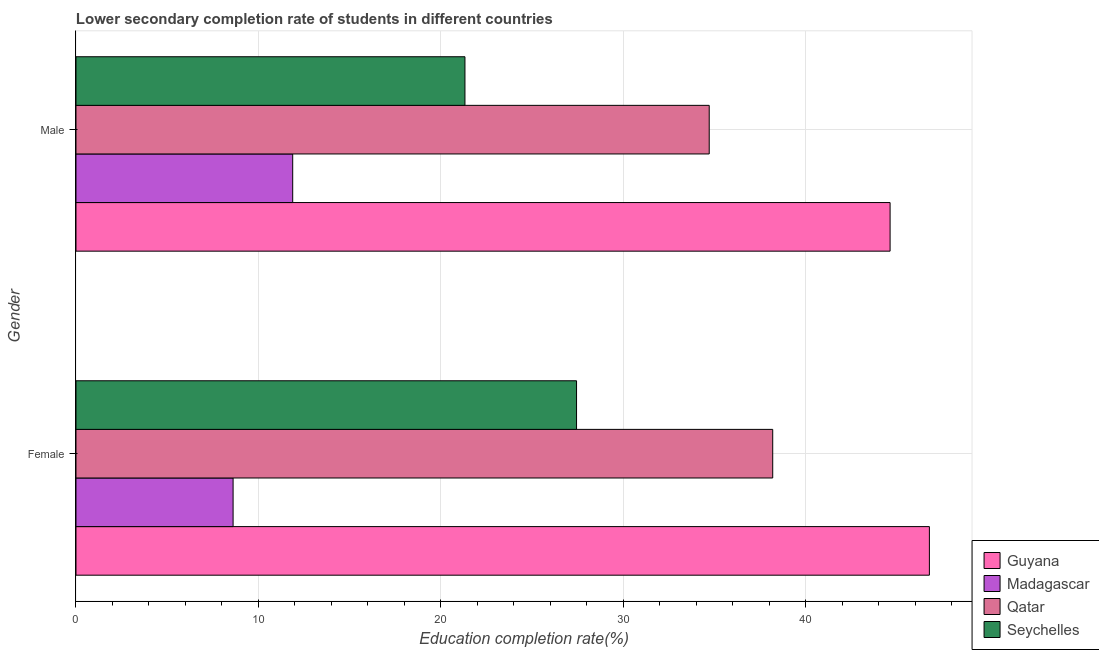Are the number of bars per tick equal to the number of legend labels?
Your answer should be compact. Yes. How many bars are there on the 1st tick from the bottom?
Give a very brief answer. 4. What is the education completion rate of female students in Qatar?
Your response must be concise. 38.18. Across all countries, what is the maximum education completion rate of male students?
Offer a terse response. 44.61. Across all countries, what is the minimum education completion rate of female students?
Your response must be concise. 8.61. In which country was the education completion rate of male students maximum?
Provide a succinct answer. Guyana. In which country was the education completion rate of female students minimum?
Offer a terse response. Madagascar. What is the total education completion rate of male students in the graph?
Give a very brief answer. 112.5. What is the difference between the education completion rate of male students in Qatar and that in Madagascar?
Make the answer very short. 22.82. What is the difference between the education completion rate of female students in Guyana and the education completion rate of male students in Madagascar?
Your answer should be very brief. 34.89. What is the average education completion rate of female students per country?
Offer a terse response. 30.24. What is the difference between the education completion rate of male students and education completion rate of female students in Guyana?
Provide a succinct answer. -2.15. What is the ratio of the education completion rate of male students in Madagascar to that in Qatar?
Offer a terse response. 0.34. What does the 4th bar from the top in Female represents?
Your response must be concise. Guyana. What does the 4th bar from the bottom in Male represents?
Offer a very short reply. Seychelles. Are all the bars in the graph horizontal?
Your answer should be very brief. Yes. Are the values on the major ticks of X-axis written in scientific E-notation?
Your answer should be compact. No. Does the graph contain any zero values?
Keep it short and to the point. No. Does the graph contain grids?
Provide a short and direct response. Yes. Where does the legend appear in the graph?
Provide a succinct answer. Bottom right. How many legend labels are there?
Offer a very short reply. 4. How are the legend labels stacked?
Ensure brevity in your answer.  Vertical. What is the title of the graph?
Ensure brevity in your answer.  Lower secondary completion rate of students in different countries. Does "Estonia" appear as one of the legend labels in the graph?
Your response must be concise. No. What is the label or title of the X-axis?
Make the answer very short. Education completion rate(%). What is the label or title of the Y-axis?
Your answer should be compact. Gender. What is the Education completion rate(%) of Guyana in Female?
Provide a short and direct response. 46.76. What is the Education completion rate(%) of Madagascar in Female?
Your answer should be very brief. 8.61. What is the Education completion rate(%) in Qatar in Female?
Ensure brevity in your answer.  38.18. What is the Education completion rate(%) in Seychelles in Female?
Provide a short and direct response. 27.43. What is the Education completion rate(%) of Guyana in Male?
Give a very brief answer. 44.61. What is the Education completion rate(%) of Madagascar in Male?
Keep it short and to the point. 11.88. What is the Education completion rate(%) in Qatar in Male?
Your answer should be compact. 34.7. What is the Education completion rate(%) of Seychelles in Male?
Ensure brevity in your answer.  21.31. Across all Gender, what is the maximum Education completion rate(%) in Guyana?
Make the answer very short. 46.76. Across all Gender, what is the maximum Education completion rate(%) in Madagascar?
Keep it short and to the point. 11.88. Across all Gender, what is the maximum Education completion rate(%) of Qatar?
Provide a short and direct response. 38.18. Across all Gender, what is the maximum Education completion rate(%) in Seychelles?
Give a very brief answer. 27.43. Across all Gender, what is the minimum Education completion rate(%) of Guyana?
Your answer should be compact. 44.61. Across all Gender, what is the minimum Education completion rate(%) of Madagascar?
Your response must be concise. 8.61. Across all Gender, what is the minimum Education completion rate(%) in Qatar?
Provide a succinct answer. 34.7. Across all Gender, what is the minimum Education completion rate(%) of Seychelles?
Your answer should be very brief. 21.31. What is the total Education completion rate(%) of Guyana in the graph?
Your response must be concise. 91.37. What is the total Education completion rate(%) in Madagascar in the graph?
Ensure brevity in your answer.  20.48. What is the total Education completion rate(%) of Qatar in the graph?
Provide a succinct answer. 72.88. What is the total Education completion rate(%) of Seychelles in the graph?
Offer a very short reply. 48.74. What is the difference between the Education completion rate(%) of Guyana in Female and that in Male?
Your response must be concise. 2.15. What is the difference between the Education completion rate(%) of Madagascar in Female and that in Male?
Ensure brevity in your answer.  -3.27. What is the difference between the Education completion rate(%) of Qatar in Female and that in Male?
Your response must be concise. 3.48. What is the difference between the Education completion rate(%) in Seychelles in Female and that in Male?
Keep it short and to the point. 6.11. What is the difference between the Education completion rate(%) of Guyana in Female and the Education completion rate(%) of Madagascar in Male?
Ensure brevity in your answer.  34.89. What is the difference between the Education completion rate(%) of Guyana in Female and the Education completion rate(%) of Qatar in Male?
Your response must be concise. 12.06. What is the difference between the Education completion rate(%) of Guyana in Female and the Education completion rate(%) of Seychelles in Male?
Your response must be concise. 25.45. What is the difference between the Education completion rate(%) in Madagascar in Female and the Education completion rate(%) in Qatar in Male?
Your response must be concise. -26.09. What is the difference between the Education completion rate(%) in Madagascar in Female and the Education completion rate(%) in Seychelles in Male?
Give a very brief answer. -12.71. What is the difference between the Education completion rate(%) in Qatar in Female and the Education completion rate(%) in Seychelles in Male?
Your answer should be very brief. 16.86. What is the average Education completion rate(%) in Guyana per Gender?
Provide a succinct answer. 45.69. What is the average Education completion rate(%) in Madagascar per Gender?
Your response must be concise. 10.24. What is the average Education completion rate(%) of Qatar per Gender?
Provide a succinct answer. 36.44. What is the average Education completion rate(%) of Seychelles per Gender?
Provide a succinct answer. 24.37. What is the difference between the Education completion rate(%) in Guyana and Education completion rate(%) in Madagascar in Female?
Offer a terse response. 38.15. What is the difference between the Education completion rate(%) of Guyana and Education completion rate(%) of Qatar in Female?
Ensure brevity in your answer.  8.59. What is the difference between the Education completion rate(%) in Guyana and Education completion rate(%) in Seychelles in Female?
Give a very brief answer. 19.33. What is the difference between the Education completion rate(%) of Madagascar and Education completion rate(%) of Qatar in Female?
Your response must be concise. -29.57. What is the difference between the Education completion rate(%) of Madagascar and Education completion rate(%) of Seychelles in Female?
Give a very brief answer. -18.82. What is the difference between the Education completion rate(%) of Qatar and Education completion rate(%) of Seychelles in Female?
Offer a very short reply. 10.75. What is the difference between the Education completion rate(%) in Guyana and Education completion rate(%) in Madagascar in Male?
Your answer should be compact. 32.74. What is the difference between the Education completion rate(%) in Guyana and Education completion rate(%) in Qatar in Male?
Provide a short and direct response. 9.91. What is the difference between the Education completion rate(%) in Guyana and Education completion rate(%) in Seychelles in Male?
Offer a terse response. 23.3. What is the difference between the Education completion rate(%) in Madagascar and Education completion rate(%) in Qatar in Male?
Offer a very short reply. -22.82. What is the difference between the Education completion rate(%) of Madagascar and Education completion rate(%) of Seychelles in Male?
Ensure brevity in your answer.  -9.44. What is the difference between the Education completion rate(%) in Qatar and Education completion rate(%) in Seychelles in Male?
Provide a succinct answer. 13.39. What is the ratio of the Education completion rate(%) in Guyana in Female to that in Male?
Your answer should be very brief. 1.05. What is the ratio of the Education completion rate(%) in Madagascar in Female to that in Male?
Provide a succinct answer. 0.72. What is the ratio of the Education completion rate(%) of Qatar in Female to that in Male?
Ensure brevity in your answer.  1.1. What is the ratio of the Education completion rate(%) in Seychelles in Female to that in Male?
Offer a terse response. 1.29. What is the difference between the highest and the second highest Education completion rate(%) of Guyana?
Give a very brief answer. 2.15. What is the difference between the highest and the second highest Education completion rate(%) in Madagascar?
Your answer should be compact. 3.27. What is the difference between the highest and the second highest Education completion rate(%) of Qatar?
Your answer should be very brief. 3.48. What is the difference between the highest and the second highest Education completion rate(%) of Seychelles?
Your response must be concise. 6.11. What is the difference between the highest and the lowest Education completion rate(%) of Guyana?
Give a very brief answer. 2.15. What is the difference between the highest and the lowest Education completion rate(%) of Madagascar?
Provide a short and direct response. 3.27. What is the difference between the highest and the lowest Education completion rate(%) in Qatar?
Your answer should be compact. 3.48. What is the difference between the highest and the lowest Education completion rate(%) in Seychelles?
Offer a very short reply. 6.11. 